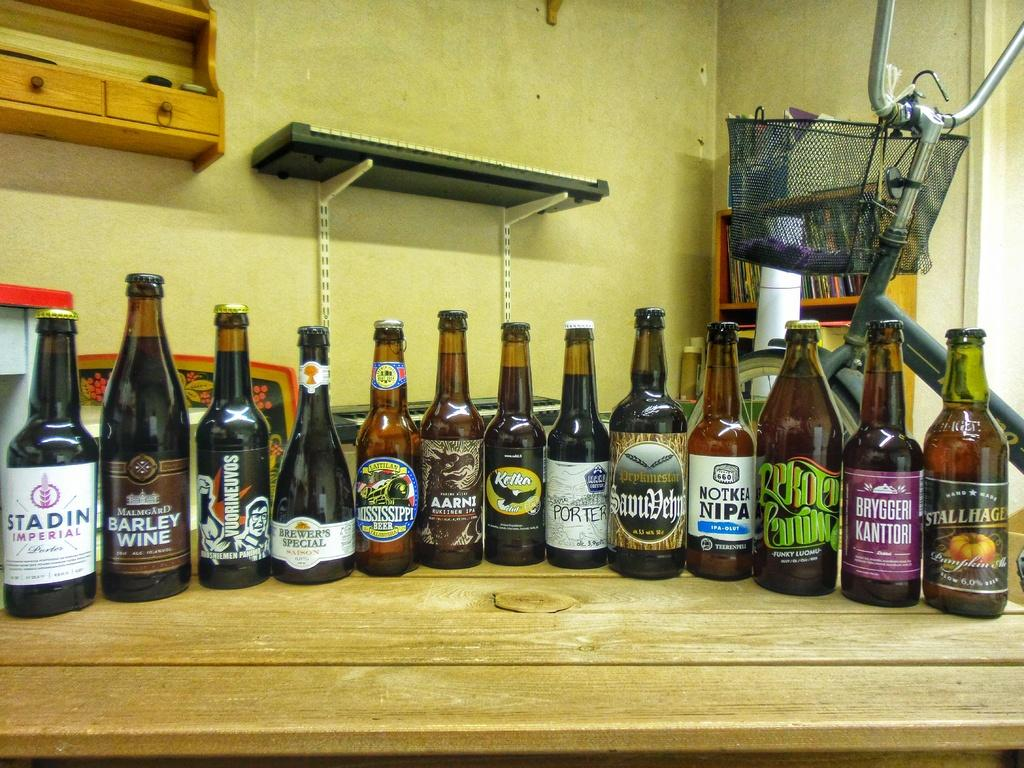<image>
Present a compact description of the photo's key features. A bunch of beer bottles lined up on a counter and one is called Notkea Nipa. 